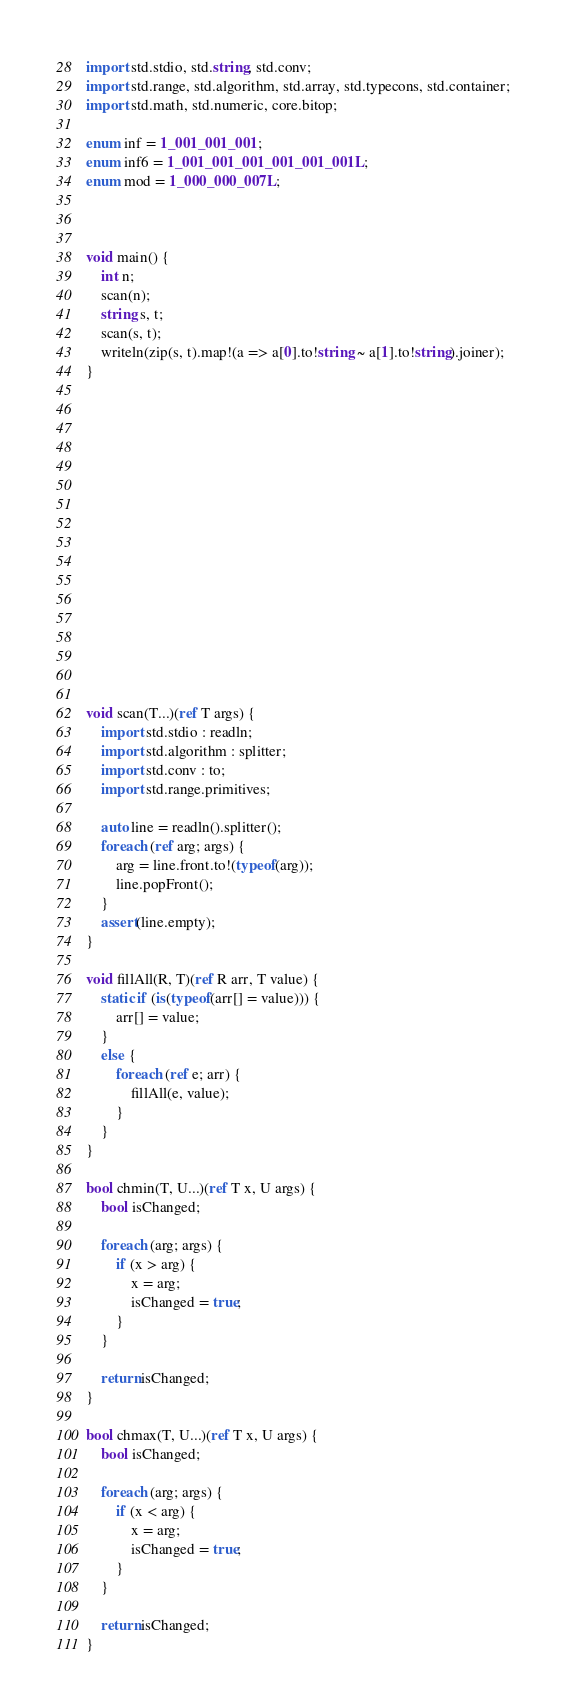Convert code to text. <code><loc_0><loc_0><loc_500><loc_500><_D_>import std.stdio, std.string, std.conv;
import std.range, std.algorithm, std.array, std.typecons, std.container;
import std.math, std.numeric, core.bitop;

enum inf = 1_001_001_001;
enum inf6 = 1_001_001_001_001_001_001L;
enum mod = 1_000_000_007L;



void main() {
    int n;
    scan(n);
    string s, t;
    scan(s, t);
    writeln(zip(s, t).map!(a => a[0].to!string ~ a[1].to!string).joiner);
}

















void scan(T...)(ref T args) {
    import std.stdio : readln;
    import std.algorithm : splitter;
    import std.conv : to;
    import std.range.primitives;

    auto line = readln().splitter();
    foreach (ref arg; args) {
        arg = line.front.to!(typeof(arg));
        line.popFront();
    }
    assert(line.empty);
}

void fillAll(R, T)(ref R arr, T value) {
    static if (is(typeof(arr[] = value))) {
        arr[] = value;
    }
    else {
        foreach (ref e; arr) {
            fillAll(e, value);
        }
    }
}

bool chmin(T, U...)(ref T x, U args) {
    bool isChanged;

    foreach (arg; args) {
        if (x > arg) {
            x = arg;
            isChanged = true;
        }
    }

    return isChanged;
}

bool chmax(T, U...)(ref T x, U args) {
    bool isChanged;

    foreach (arg; args) {
        if (x < arg) {
            x = arg;
            isChanged = true;
        }
    }

    return isChanged;
}
</code> 